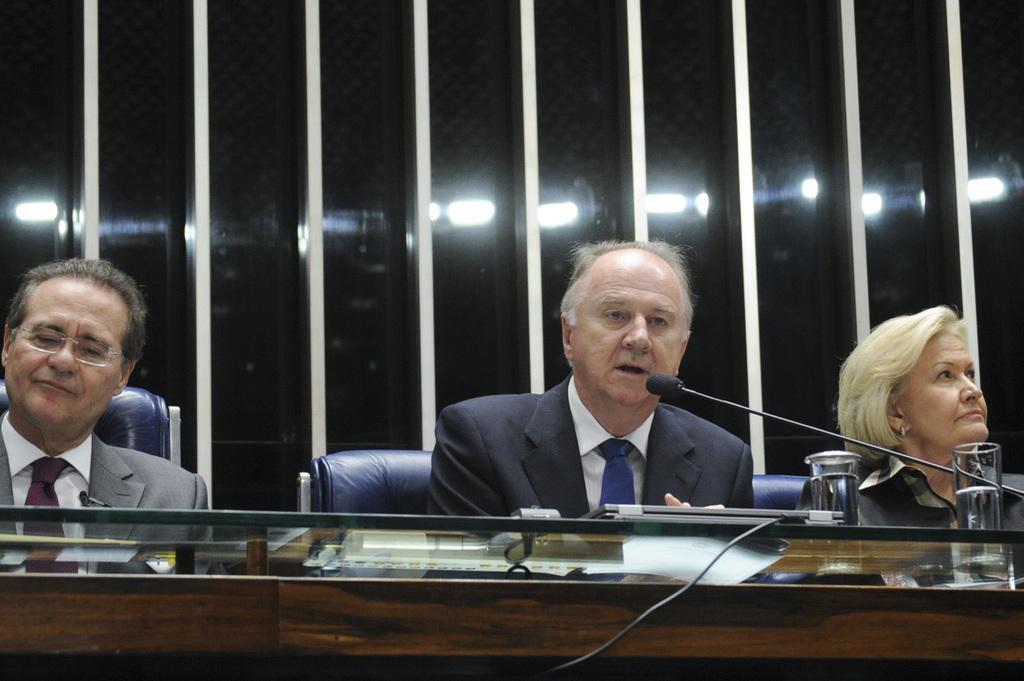How would you summarize this image in a sentence or two? At the bottom of the image there is a table. On the table there are glasses with water and also there is a mic. At the right corner of the image behind the table there is a lady sitting on the chair. Beside her to the left side there is a man with black jacket, white shirt and blue tie is sitting and in front of him there is a mic and he is talking. At the left corner of the image there is a man with grey jacket, white shirt and purple tie is sitting and he kept spectacles. Behind them there is a black wall with white poles. 